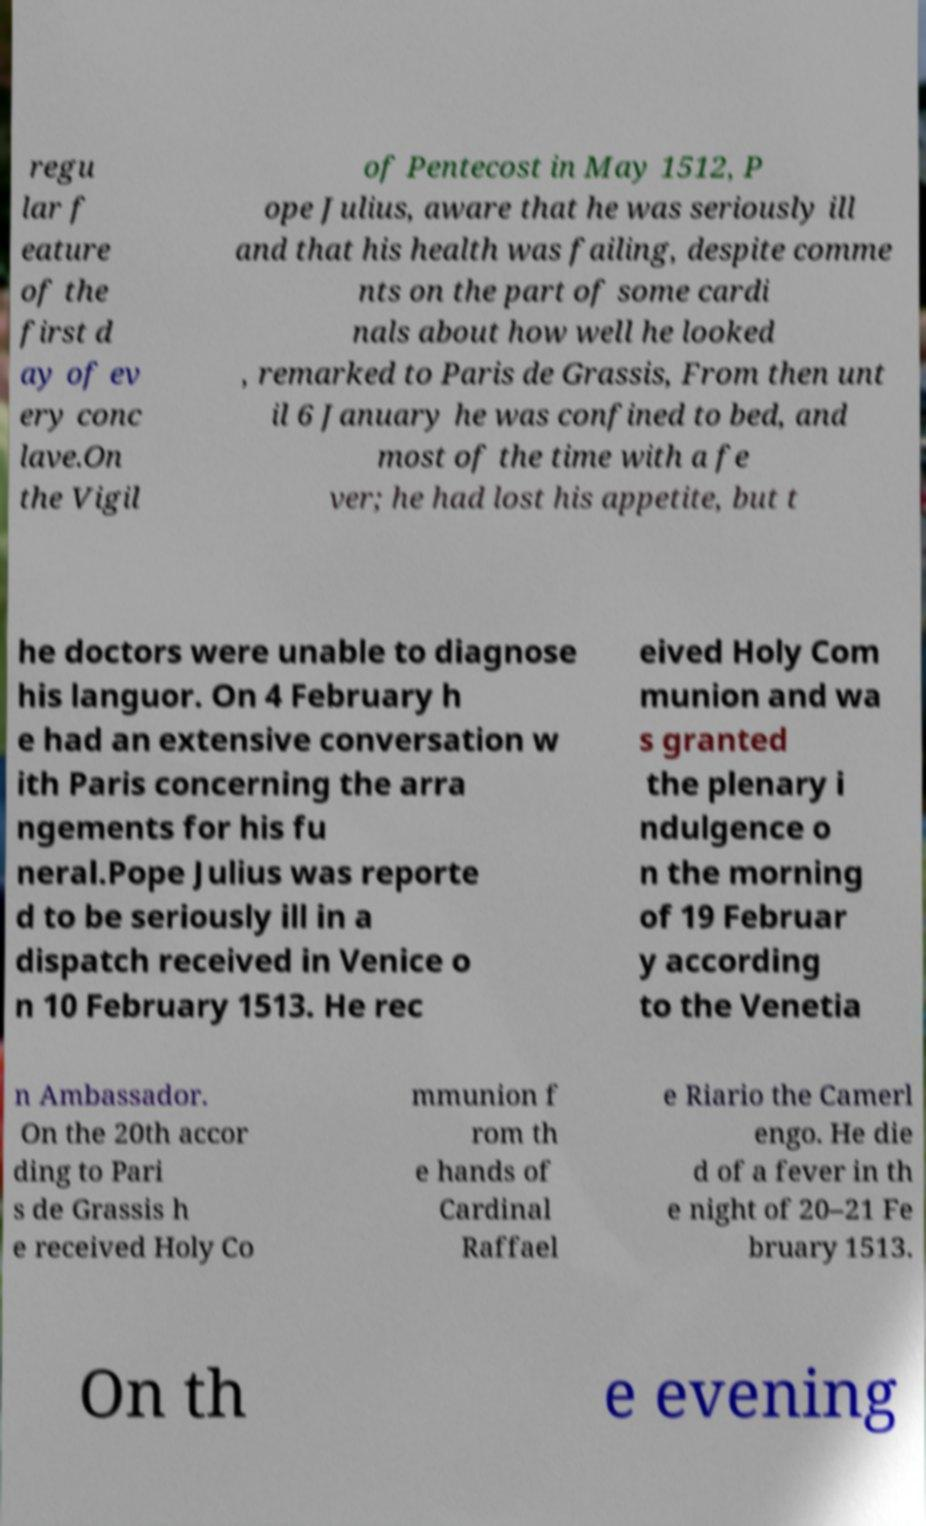There's text embedded in this image that I need extracted. Can you transcribe it verbatim? regu lar f eature of the first d ay of ev ery conc lave.On the Vigil of Pentecost in May 1512, P ope Julius, aware that he was seriously ill and that his health was failing, despite comme nts on the part of some cardi nals about how well he looked , remarked to Paris de Grassis, From then unt il 6 January he was confined to bed, and most of the time with a fe ver; he had lost his appetite, but t he doctors were unable to diagnose his languor. On 4 February h e had an extensive conversation w ith Paris concerning the arra ngements for his fu neral.Pope Julius was reporte d to be seriously ill in a dispatch received in Venice o n 10 February 1513. He rec eived Holy Com munion and wa s granted the plenary i ndulgence o n the morning of 19 Februar y according to the Venetia n Ambassador. On the 20th accor ding to Pari s de Grassis h e received Holy Co mmunion f rom th e hands of Cardinal Raffael e Riario the Camerl engo. He die d of a fever in th e night of 20–21 Fe bruary 1513. On th e evening 